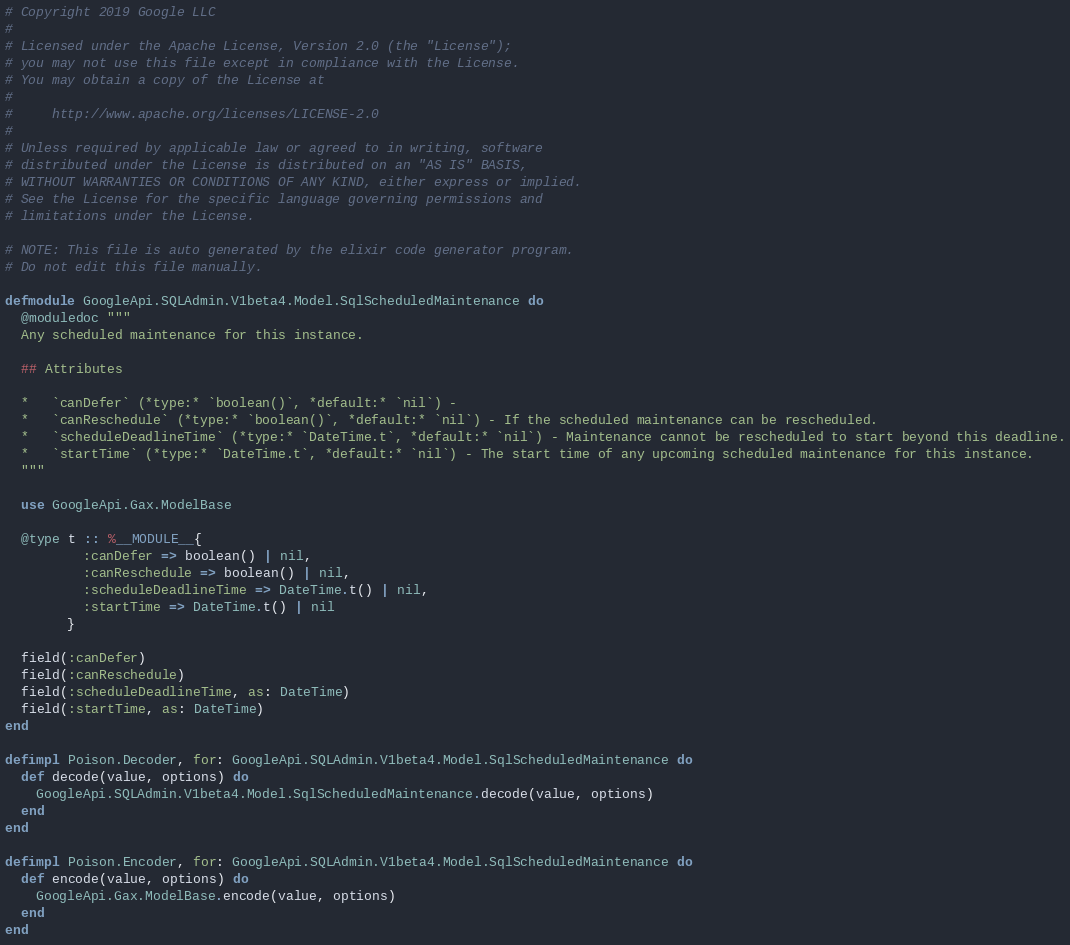Convert code to text. <code><loc_0><loc_0><loc_500><loc_500><_Elixir_># Copyright 2019 Google LLC
#
# Licensed under the Apache License, Version 2.0 (the "License");
# you may not use this file except in compliance with the License.
# You may obtain a copy of the License at
#
#     http://www.apache.org/licenses/LICENSE-2.0
#
# Unless required by applicable law or agreed to in writing, software
# distributed under the License is distributed on an "AS IS" BASIS,
# WITHOUT WARRANTIES OR CONDITIONS OF ANY KIND, either express or implied.
# See the License for the specific language governing permissions and
# limitations under the License.

# NOTE: This file is auto generated by the elixir code generator program.
# Do not edit this file manually.

defmodule GoogleApi.SQLAdmin.V1beta4.Model.SqlScheduledMaintenance do
  @moduledoc """
  Any scheduled maintenance for this instance.

  ## Attributes

  *   `canDefer` (*type:* `boolean()`, *default:* `nil`) - 
  *   `canReschedule` (*type:* `boolean()`, *default:* `nil`) - If the scheduled maintenance can be rescheduled.
  *   `scheduleDeadlineTime` (*type:* `DateTime.t`, *default:* `nil`) - Maintenance cannot be rescheduled to start beyond this deadline.
  *   `startTime` (*type:* `DateTime.t`, *default:* `nil`) - The start time of any upcoming scheduled maintenance for this instance.
  """

  use GoogleApi.Gax.ModelBase

  @type t :: %__MODULE__{
          :canDefer => boolean() | nil,
          :canReschedule => boolean() | nil,
          :scheduleDeadlineTime => DateTime.t() | nil,
          :startTime => DateTime.t() | nil
        }

  field(:canDefer)
  field(:canReschedule)
  field(:scheduleDeadlineTime, as: DateTime)
  field(:startTime, as: DateTime)
end

defimpl Poison.Decoder, for: GoogleApi.SQLAdmin.V1beta4.Model.SqlScheduledMaintenance do
  def decode(value, options) do
    GoogleApi.SQLAdmin.V1beta4.Model.SqlScheduledMaintenance.decode(value, options)
  end
end

defimpl Poison.Encoder, for: GoogleApi.SQLAdmin.V1beta4.Model.SqlScheduledMaintenance do
  def encode(value, options) do
    GoogleApi.Gax.ModelBase.encode(value, options)
  end
end
</code> 